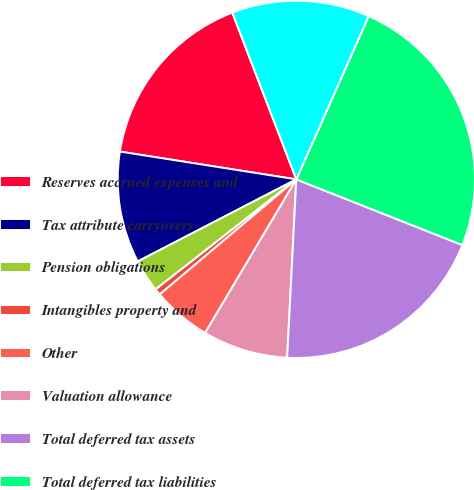<chart> <loc_0><loc_0><loc_500><loc_500><pie_chart><fcel>Reserves accrued expenses and<fcel>Tax attribute carryovers<fcel>Pension obligations<fcel>Intangibles property and<fcel>Other<fcel>Valuation allowance<fcel>Total deferred tax assets<fcel>Total deferred tax liabilities<fcel>Net deferred tax liability (a)<nl><fcel>16.68%<fcel>10.09%<fcel>2.96%<fcel>0.58%<fcel>5.33%<fcel>7.71%<fcel>19.82%<fcel>24.36%<fcel>12.47%<nl></chart> 